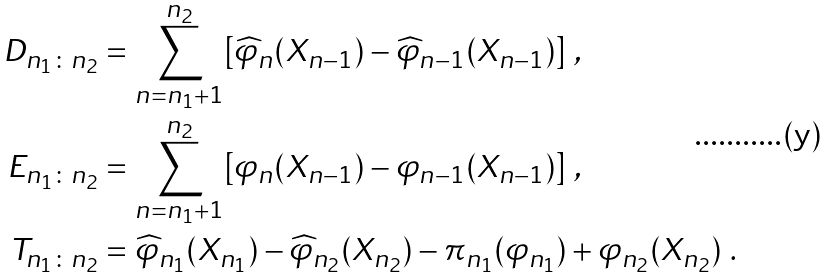<formula> <loc_0><loc_0><loc_500><loc_500>D _ { n _ { 1 } \colon n _ { 2 } } & = \sum _ { n = n _ { 1 } + 1 } ^ { n _ { 2 } } [ \widehat { \varphi } _ { n } ( X _ { n - 1 } ) - \widehat { \varphi } _ { n - 1 } ( X _ { n - 1 } ) ] \ , \\ E _ { n _ { 1 } \colon n _ { 2 } } & = \sum _ { n = n _ { 1 } + 1 } ^ { n _ { 2 } } [ \varphi _ { n } ( X _ { n - 1 } ) - \varphi _ { n - 1 } ( X _ { n - 1 } ) ] \ , \\ T _ { n _ { 1 } \colon n _ { 2 } } & = \widehat { \varphi } _ { n _ { 1 } } ( X _ { n _ { 1 } } ) - \widehat { \varphi } _ { n _ { 2 } } ( X _ { n _ { 2 } } ) - \pi _ { n _ { 1 } } ( \varphi _ { n _ { 1 } } ) + { \varphi } _ { n _ { 2 } } ( X _ { n _ { 2 } } ) \ .</formula> 